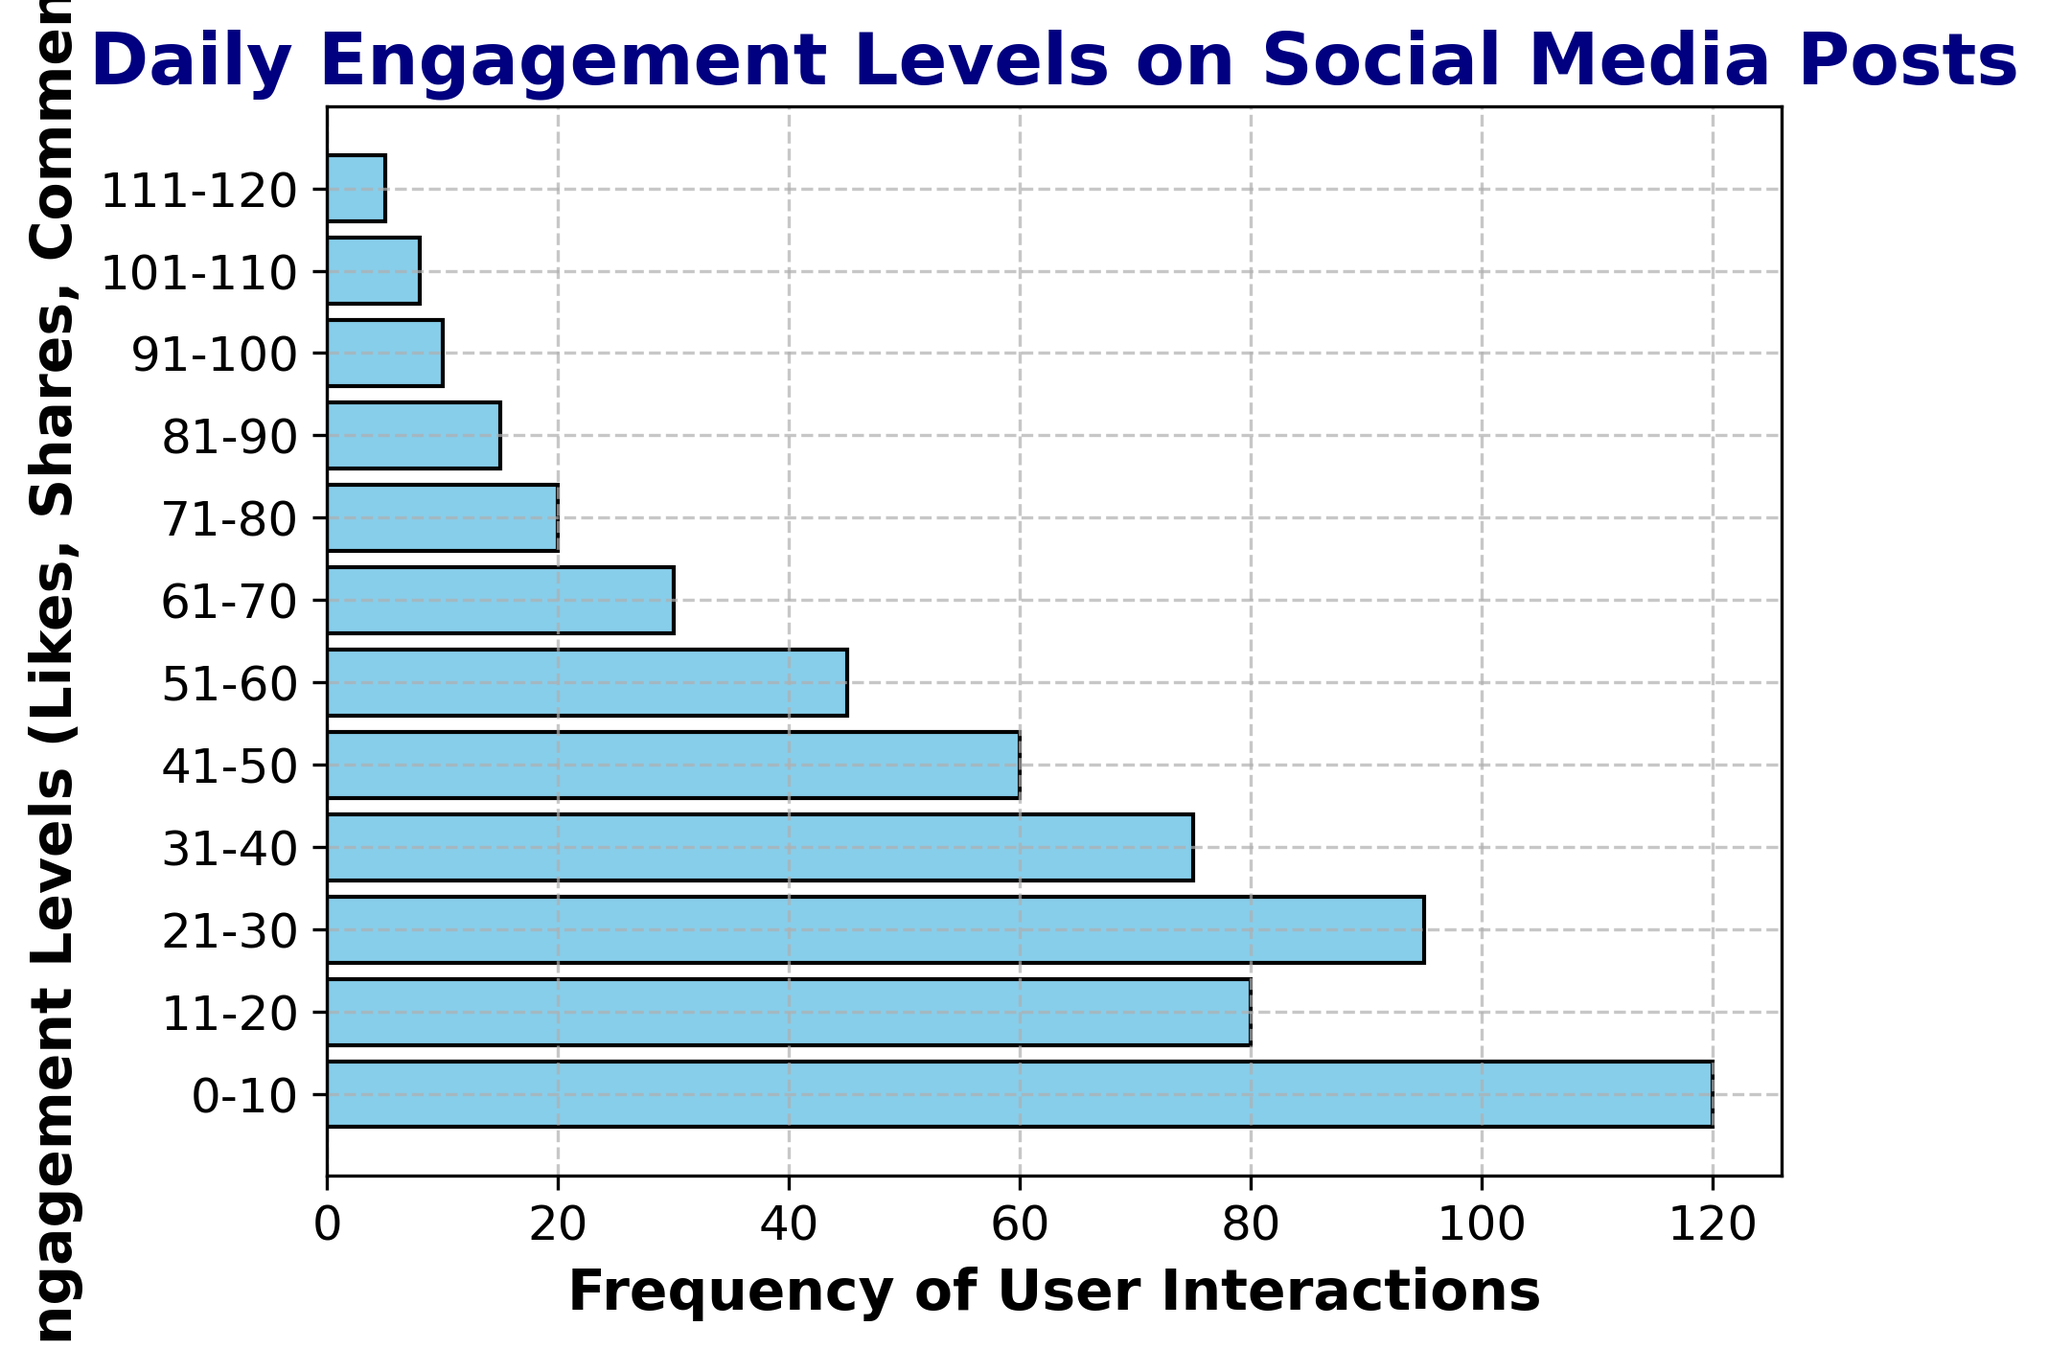Which engagement level has the highest daily frequency? The figure shows the height of various horizontal bars representing daily frequencies for different engagement levels. The tallest bar corresponds to the engagement level "0-10," with a frequency of 120.
Answer: 0-10 How many engagement levels have a daily frequency of 100 or more? Inspect the figure and identify bars with frequencies at or above 100. Only one bar meets this criterion: the "0-10" engagement level, with a frequency of 120.
Answer: 1 Which engagement level range has the least daily frequency? The shortest bar represents the lowest daily frequency. The "111-120" engagement level has the least daily frequency, which is indicated as 5.
Answer: 111-120 What is the combined frequency of engagement levels from "41-50" to "81-90"? Sum the frequencies for the relevant engagement levels. The frequencies are: "41-50" (60), "51-60" (45), "61-70" (30), "71-80" (20), and "81-90" (15). The total is 60 + 45 + 30 + 20 + 15 = 170.
Answer: 170 Are there more engagement levels with daily frequencies above or below 50? Count the number of engagement levels with frequencies greater than 50 and compare it to the count of those with frequencies 50 or below. Three have frequencies above 50 ("0-10", "11-20", "21-30"), and nine have frequencies 50 or below.
Answer: Below Is the frequency of engagement levels between "21-30" greater than that of "31-40"? Compare the frequencies of the two engagement levels. "21-30" has a frequency of 95, while "31-40" has a frequency of 75.
Answer: Yes What is the difference in frequency between the "0-10" and "101-110" engagement levels? Subtract the frequency of "101-110" (8) from the frequency of "0-10" (120). The difference is 120 - 8 = 112.
Answer: 112 What is the average frequency for engagement levels in the range "51-60" through "81-90"? Calculate the average frequency for four levels: "51-60" (45), "61-70" (30), "71-80" (20), "81-90" (15). The total sum is 45 + 30 + 20 + 15 = 110, and the average is 110 / 4 = 27.5.
Answer: 27.5 Which engagement level ranges are represented with bars colored in sky blue? Inspect the color of the bars; all bars in the figure are sky blue. Thus, all engagement level ranges (0-10, 11-20, ..., 111-120) are colored sky blue.
Answer: All 